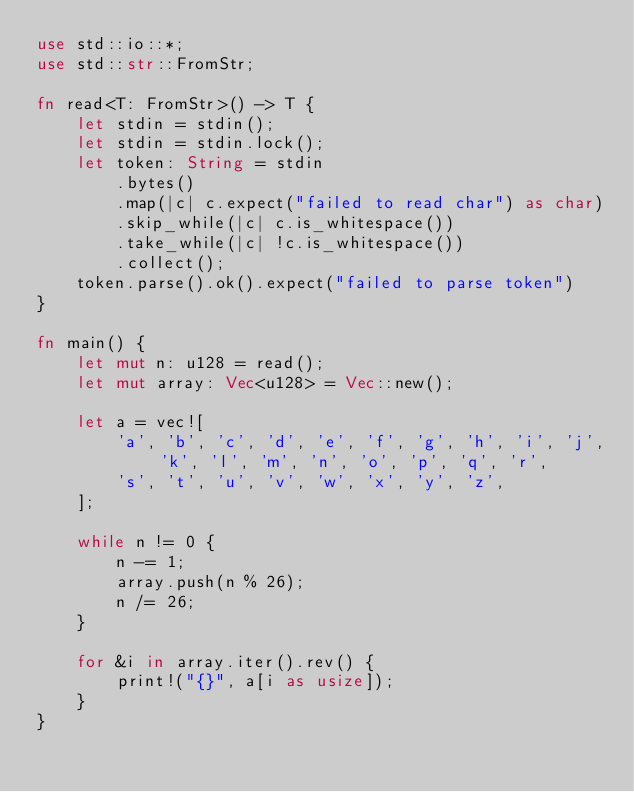Convert code to text. <code><loc_0><loc_0><loc_500><loc_500><_Rust_>use std::io::*;
use std::str::FromStr;

fn read<T: FromStr>() -> T {
    let stdin = stdin();
    let stdin = stdin.lock();
    let token: String = stdin
        .bytes()
        .map(|c| c.expect("failed to read char") as char)
        .skip_while(|c| c.is_whitespace())
        .take_while(|c| !c.is_whitespace())
        .collect();
    token.parse().ok().expect("failed to parse token")
}

fn main() {
    let mut n: u128 = read();
    let mut array: Vec<u128> = Vec::new();

    let a = vec![
        'a', 'b', 'c', 'd', 'e', 'f', 'g', 'h', 'i', 'j', 'k', 'l', 'm', 'n', 'o', 'p', 'q', 'r',
        's', 't', 'u', 'v', 'w', 'x', 'y', 'z',
    ];

    while n != 0 {
        n -= 1;
        array.push(n % 26);
        n /= 26;
    }

    for &i in array.iter().rev() {
        print!("{}", a[i as usize]);
    }
}
</code> 